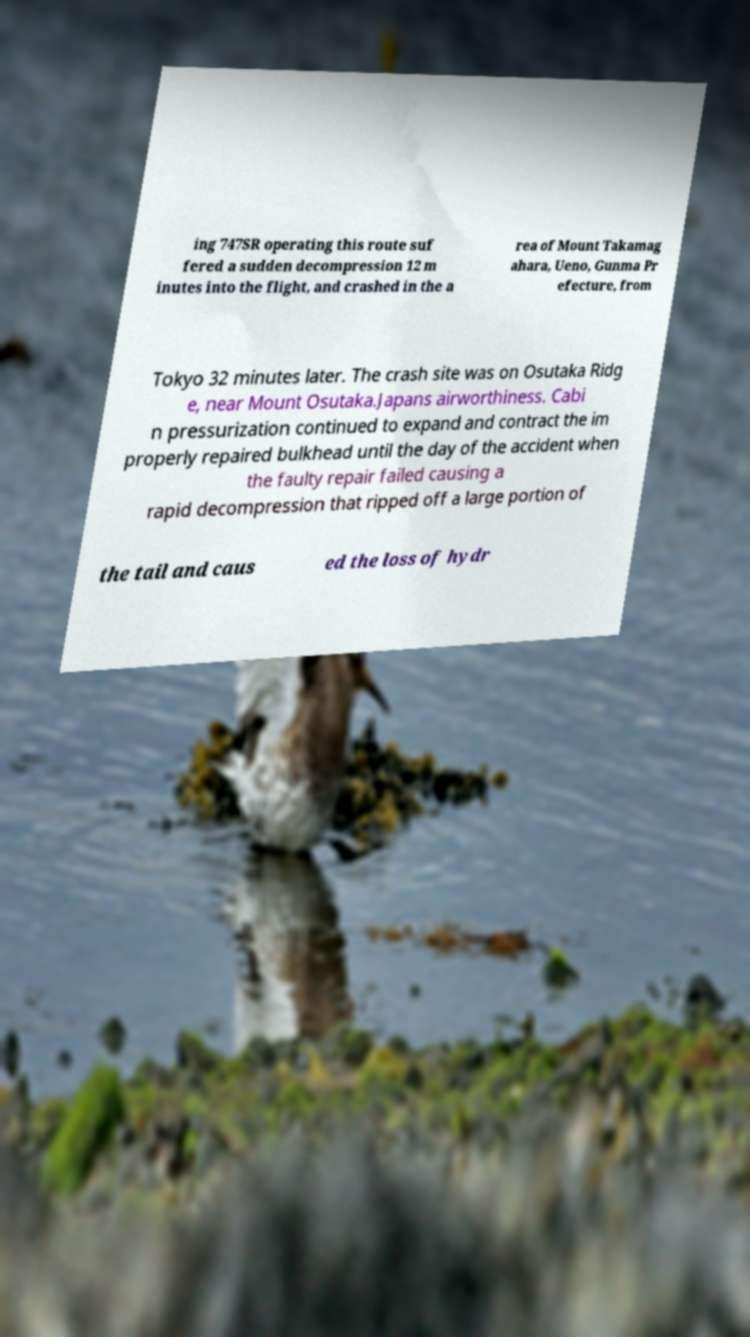For documentation purposes, I need the text within this image transcribed. Could you provide that? ing 747SR operating this route suf fered a sudden decompression 12 m inutes into the flight, and crashed in the a rea of Mount Takamag ahara, Ueno, Gunma Pr efecture, from Tokyo 32 minutes later. The crash site was on Osutaka Ridg e, near Mount Osutaka.Japans airworthiness. Cabi n pressurization continued to expand and contract the im properly repaired bulkhead until the day of the accident when the faulty repair failed causing a rapid decompression that ripped off a large portion of the tail and caus ed the loss of hydr 